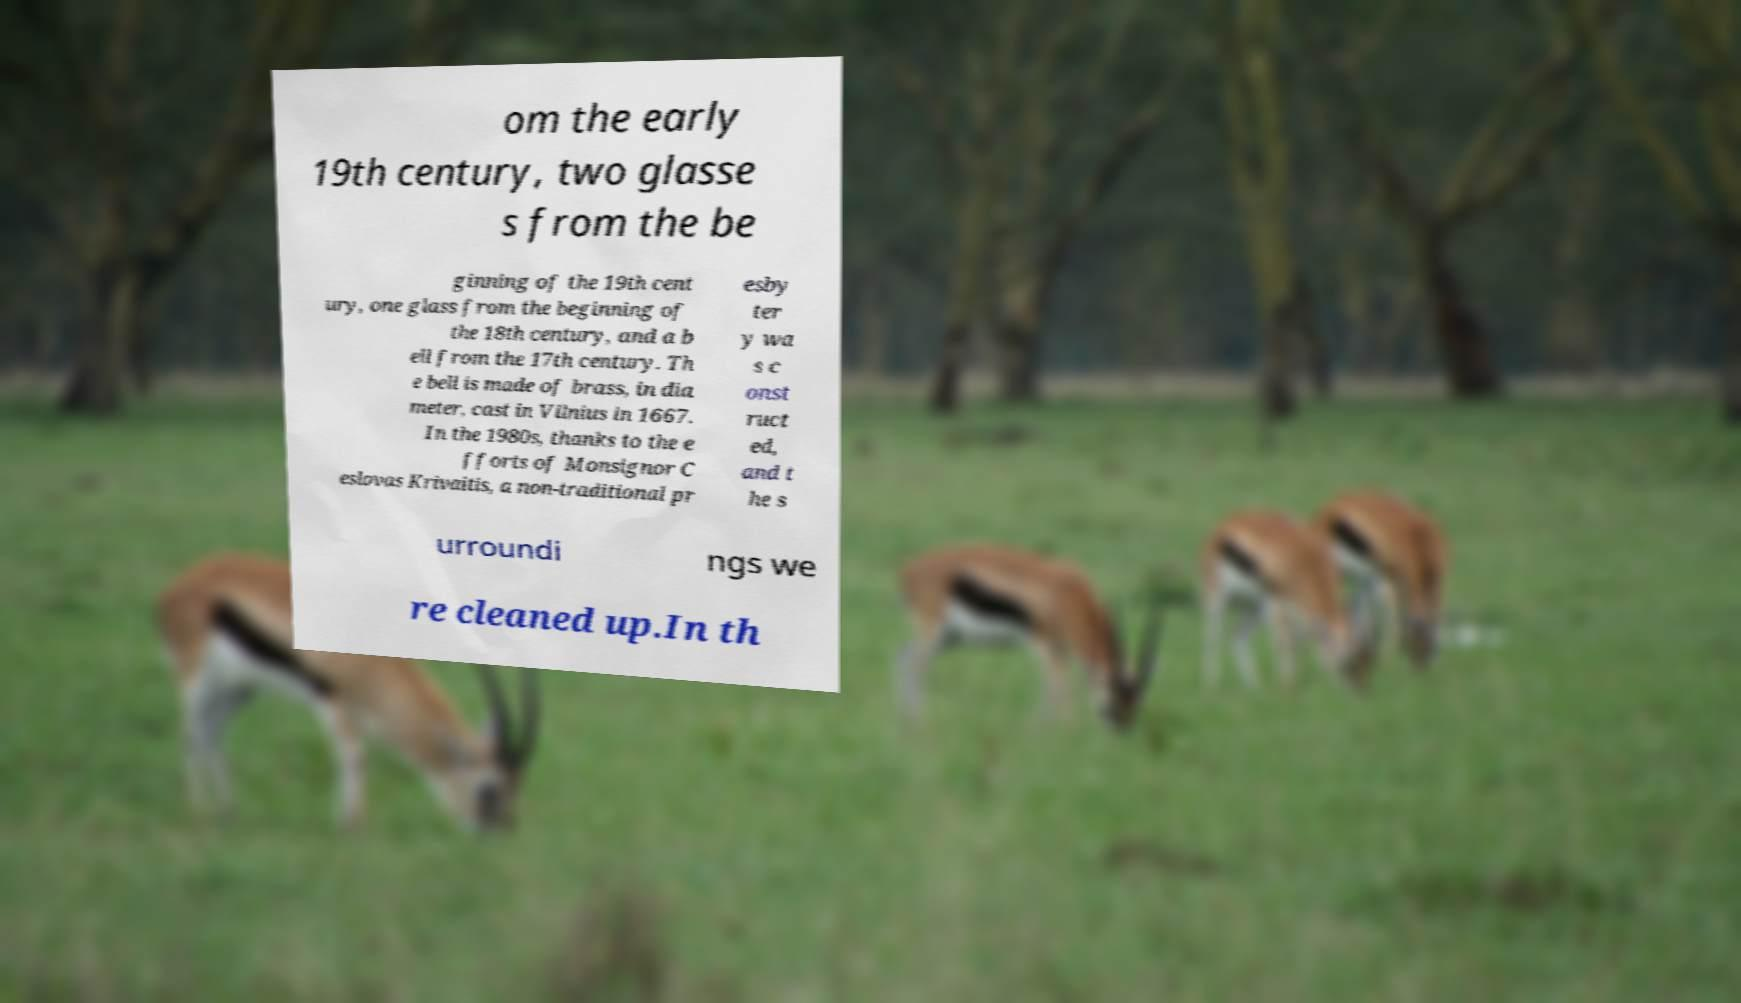Can you read and provide the text displayed in the image?This photo seems to have some interesting text. Can you extract and type it out for me? om the early 19th century, two glasse s from the be ginning of the 19th cent ury, one glass from the beginning of the 18th century, and a b ell from the 17th century. Th e bell is made of brass, in dia meter, cast in Vilnius in 1667. In the 1980s, thanks to the e fforts of Monsignor C eslovas Krivaitis, a non-traditional pr esby ter y wa s c onst ruct ed, and t he s urroundi ngs we re cleaned up.In th 